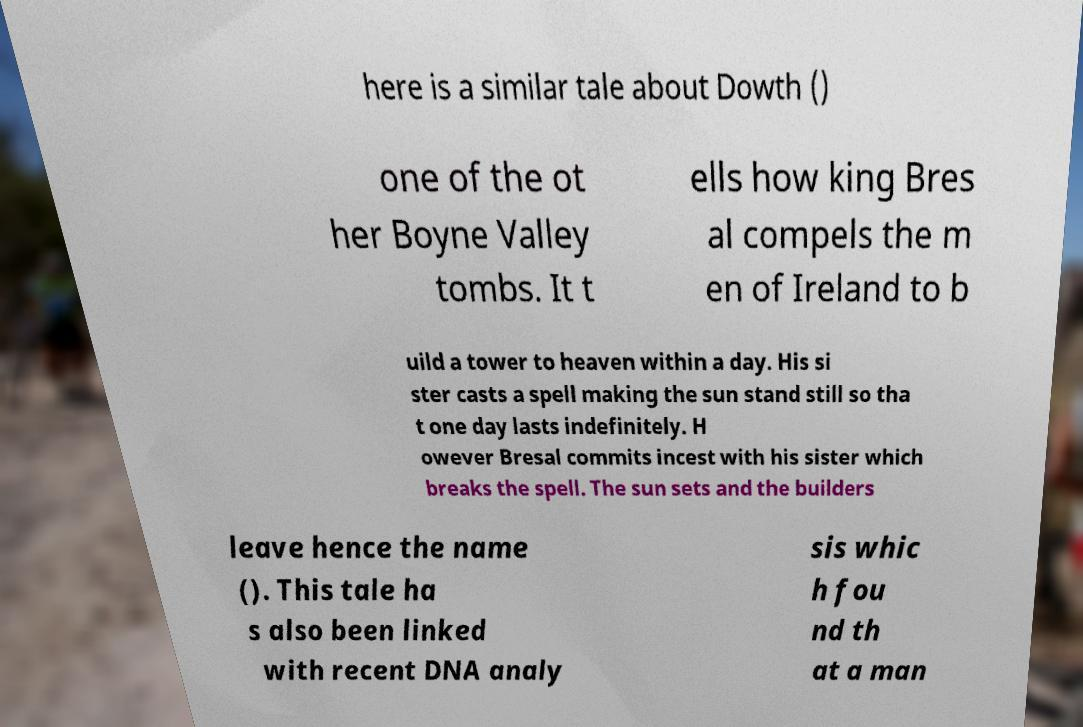Could you assist in decoding the text presented in this image and type it out clearly? here is a similar tale about Dowth () one of the ot her Boyne Valley tombs. It t ells how king Bres al compels the m en of Ireland to b uild a tower to heaven within a day. His si ster casts a spell making the sun stand still so tha t one day lasts indefinitely. H owever Bresal commits incest with his sister which breaks the spell. The sun sets and the builders leave hence the name (). This tale ha s also been linked with recent DNA analy sis whic h fou nd th at a man 